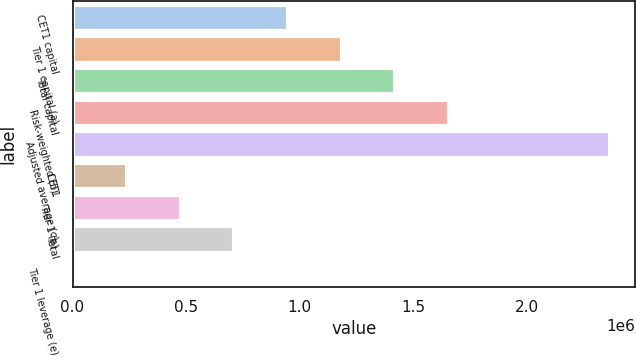Convert chart. <chart><loc_0><loc_0><loc_500><loc_500><bar_chart><fcel>CET1 capital<fcel>Tier 1 capital (a)<fcel>Total capital<fcel>Risk-weighted (b)<fcel>Adjusted average (c)<fcel>CET1<fcel>Tier 1 (a)<fcel>Total<fcel>Tier 1 leverage (e)<nl><fcel>944476<fcel>1.18059e+06<fcel>1.41671e+06<fcel>1.65283e+06<fcel>2.36118e+06<fcel>236125<fcel>472242<fcel>708359<fcel>8.5<nl></chart> 